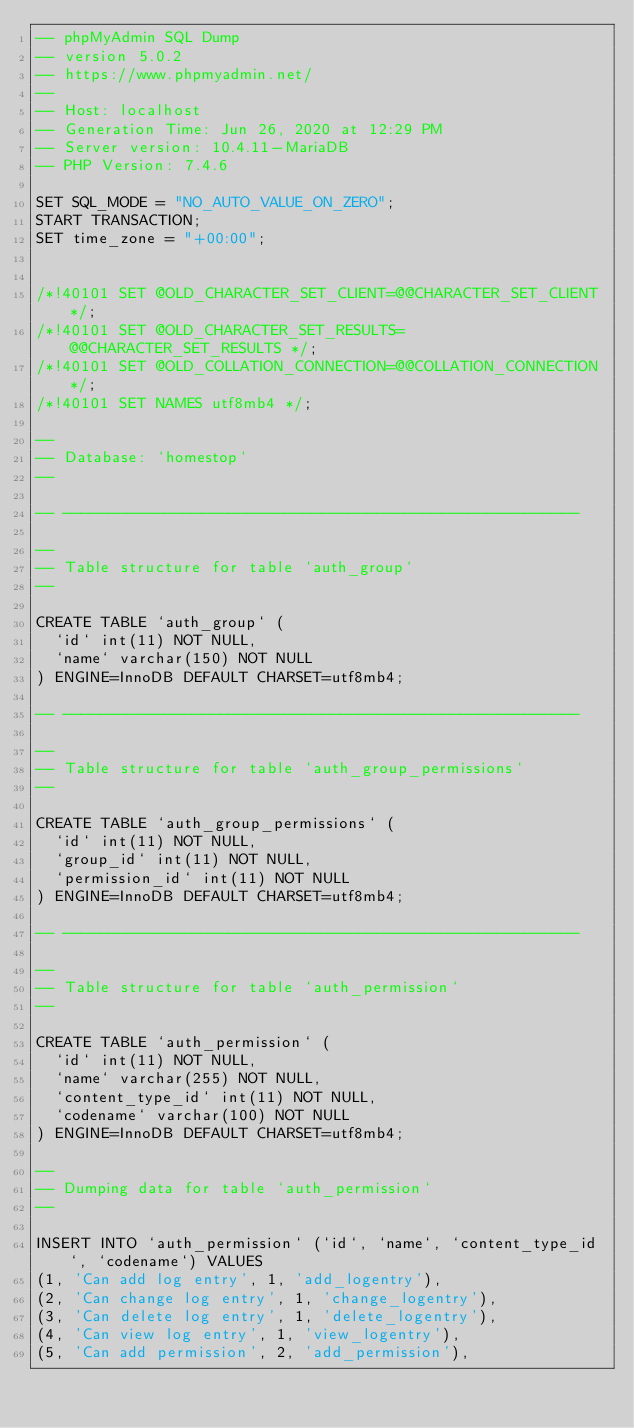Convert code to text. <code><loc_0><loc_0><loc_500><loc_500><_SQL_>-- phpMyAdmin SQL Dump
-- version 5.0.2
-- https://www.phpmyadmin.net/
--
-- Host: localhost
-- Generation Time: Jun 26, 2020 at 12:29 PM
-- Server version: 10.4.11-MariaDB
-- PHP Version: 7.4.6

SET SQL_MODE = "NO_AUTO_VALUE_ON_ZERO";
START TRANSACTION;
SET time_zone = "+00:00";


/*!40101 SET @OLD_CHARACTER_SET_CLIENT=@@CHARACTER_SET_CLIENT */;
/*!40101 SET @OLD_CHARACTER_SET_RESULTS=@@CHARACTER_SET_RESULTS */;
/*!40101 SET @OLD_COLLATION_CONNECTION=@@COLLATION_CONNECTION */;
/*!40101 SET NAMES utf8mb4 */;

--
-- Database: `homestop`
--

-- --------------------------------------------------------

--
-- Table structure for table `auth_group`
--

CREATE TABLE `auth_group` (
  `id` int(11) NOT NULL,
  `name` varchar(150) NOT NULL
) ENGINE=InnoDB DEFAULT CHARSET=utf8mb4;

-- --------------------------------------------------------

--
-- Table structure for table `auth_group_permissions`
--

CREATE TABLE `auth_group_permissions` (
  `id` int(11) NOT NULL,
  `group_id` int(11) NOT NULL,
  `permission_id` int(11) NOT NULL
) ENGINE=InnoDB DEFAULT CHARSET=utf8mb4;

-- --------------------------------------------------------

--
-- Table structure for table `auth_permission`
--

CREATE TABLE `auth_permission` (
  `id` int(11) NOT NULL,
  `name` varchar(255) NOT NULL,
  `content_type_id` int(11) NOT NULL,
  `codename` varchar(100) NOT NULL
) ENGINE=InnoDB DEFAULT CHARSET=utf8mb4;

--
-- Dumping data for table `auth_permission`
--

INSERT INTO `auth_permission` (`id`, `name`, `content_type_id`, `codename`) VALUES
(1, 'Can add log entry', 1, 'add_logentry'),
(2, 'Can change log entry', 1, 'change_logentry'),
(3, 'Can delete log entry', 1, 'delete_logentry'),
(4, 'Can view log entry', 1, 'view_logentry'),
(5, 'Can add permission', 2, 'add_permission'),</code> 